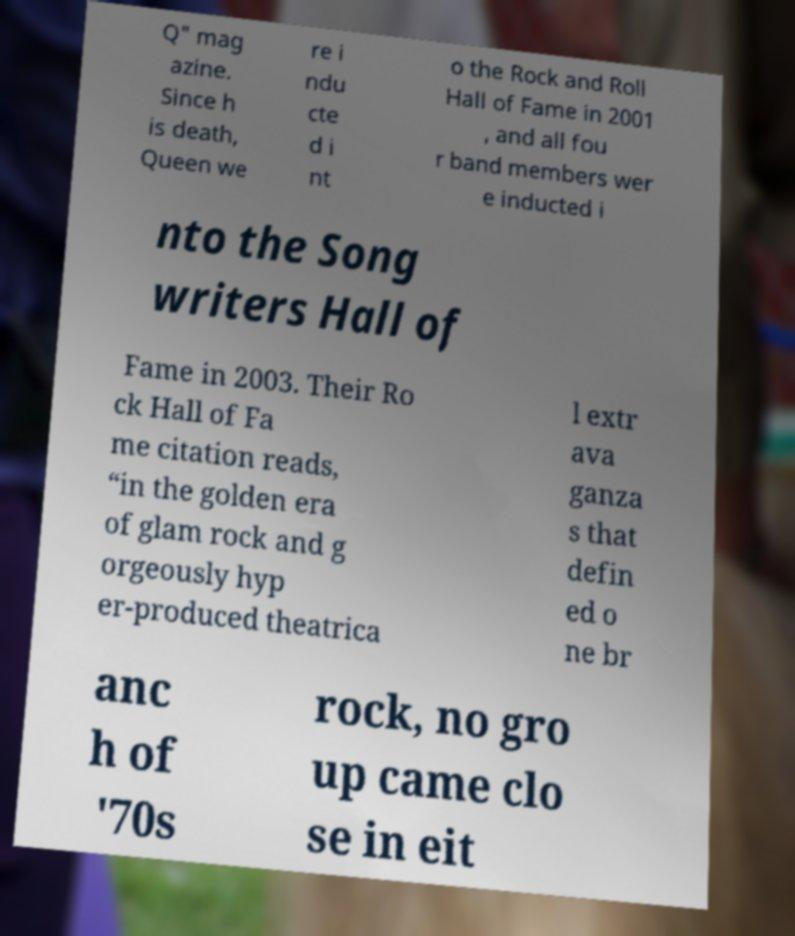Could you extract and type out the text from this image? Q" mag azine. Since h is death, Queen we re i ndu cte d i nt o the Rock and Roll Hall of Fame in 2001 , and all fou r band members wer e inducted i nto the Song writers Hall of Fame in 2003. Their Ro ck Hall of Fa me citation reads, “in the golden era of glam rock and g orgeously hyp er-produced theatrica l extr ava ganza s that defin ed o ne br anc h of '70s rock, no gro up came clo se in eit 